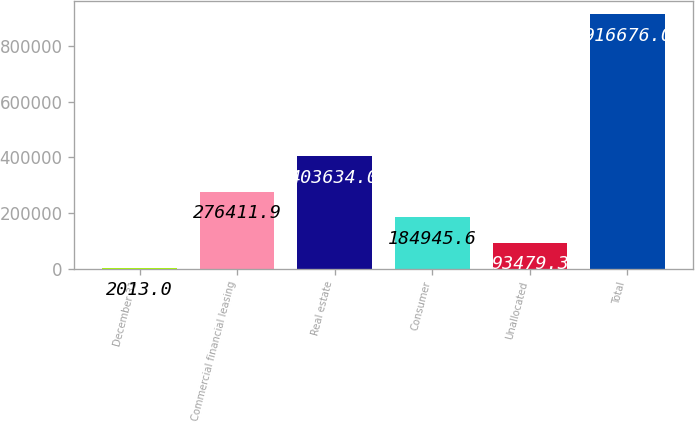<chart> <loc_0><loc_0><loc_500><loc_500><bar_chart><fcel>December 31<fcel>Commercial financial leasing<fcel>Real estate<fcel>Consumer<fcel>Unallocated<fcel>Total<nl><fcel>2013<fcel>276412<fcel>403634<fcel>184946<fcel>93479.3<fcel>916676<nl></chart> 